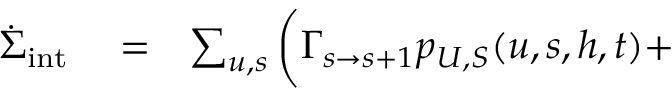Convert formula to latex. <formula><loc_0><loc_0><loc_500><loc_500>\begin{array} { r l r } { \dot { \Sigma } _ { i n t } } & = } & { \sum _ { u , s } \Big ( \Gamma _ { s \to s + 1 } p _ { U , S } ( u , s , h , t ) + } \end{array}</formula> 